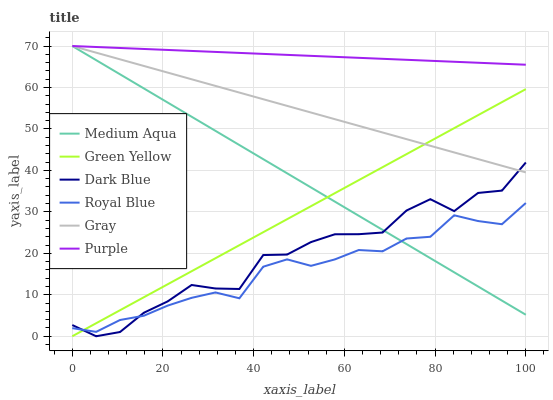Does Royal Blue have the minimum area under the curve?
Answer yes or no. Yes. Does Purple have the maximum area under the curve?
Answer yes or no. Yes. Does Purple have the minimum area under the curve?
Answer yes or no. No. Does Royal Blue have the maximum area under the curve?
Answer yes or no. No. Is Green Yellow the smoothest?
Answer yes or no. Yes. Is Dark Blue the roughest?
Answer yes or no. Yes. Is Royal Blue the smoothest?
Answer yes or no. No. Is Royal Blue the roughest?
Answer yes or no. No. Does Dark Blue have the lowest value?
Answer yes or no. Yes. Does Royal Blue have the lowest value?
Answer yes or no. No. Does Medium Aqua have the highest value?
Answer yes or no. Yes. Does Royal Blue have the highest value?
Answer yes or no. No. Is Royal Blue less than Gray?
Answer yes or no. Yes. Is Purple greater than Dark Blue?
Answer yes or no. Yes. Does Dark Blue intersect Medium Aqua?
Answer yes or no. Yes. Is Dark Blue less than Medium Aqua?
Answer yes or no. No. Is Dark Blue greater than Medium Aqua?
Answer yes or no. No. Does Royal Blue intersect Gray?
Answer yes or no. No. 